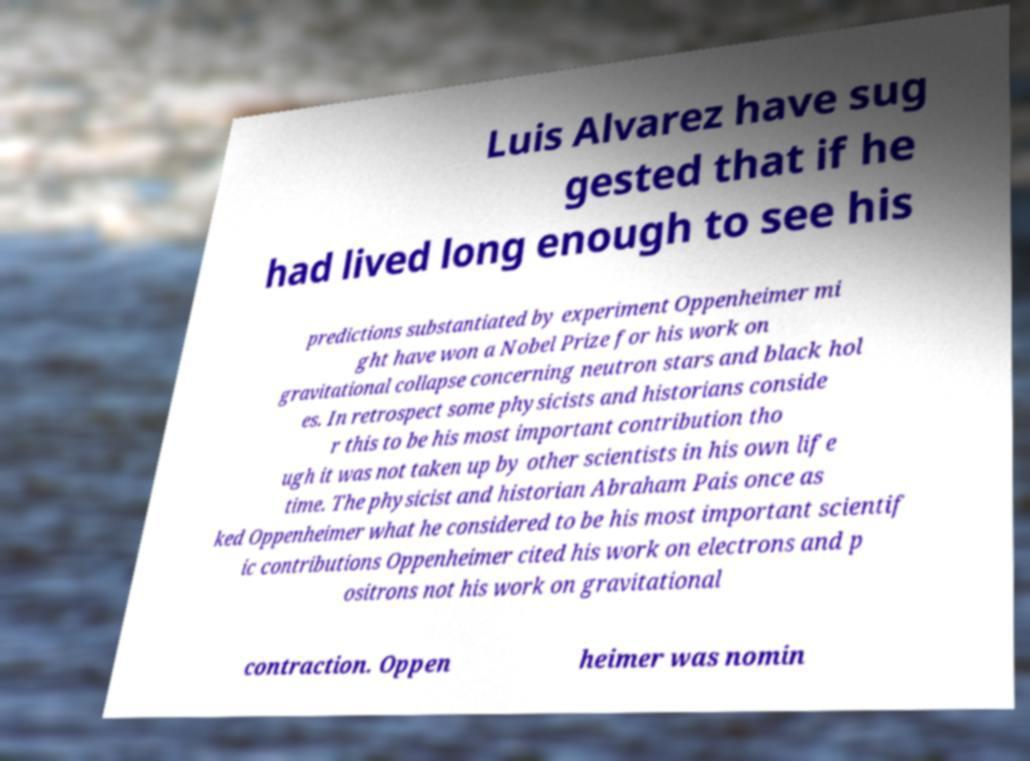Could you assist in decoding the text presented in this image and type it out clearly? Luis Alvarez have sug gested that if he had lived long enough to see his predictions substantiated by experiment Oppenheimer mi ght have won a Nobel Prize for his work on gravitational collapse concerning neutron stars and black hol es. In retrospect some physicists and historians conside r this to be his most important contribution tho ugh it was not taken up by other scientists in his own life time. The physicist and historian Abraham Pais once as ked Oppenheimer what he considered to be his most important scientif ic contributions Oppenheimer cited his work on electrons and p ositrons not his work on gravitational contraction. Oppen heimer was nomin 